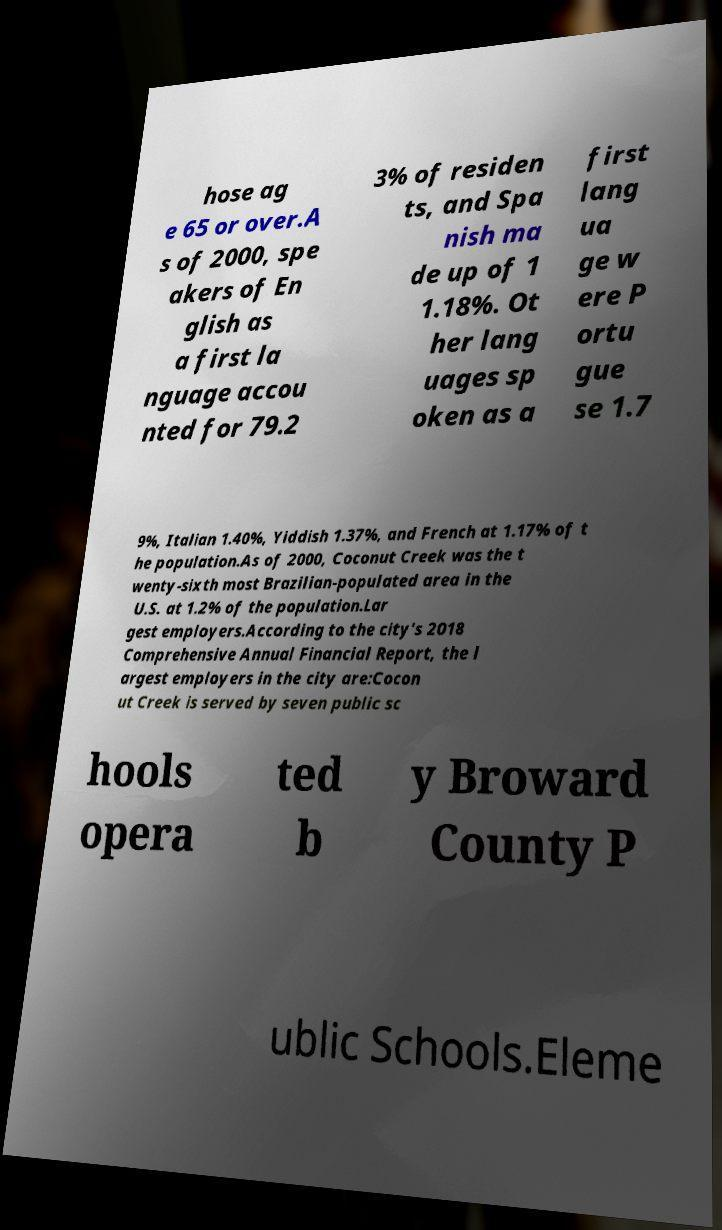I need the written content from this picture converted into text. Can you do that? hose ag e 65 or over.A s of 2000, spe akers of En glish as a first la nguage accou nted for 79.2 3% of residen ts, and Spa nish ma de up of 1 1.18%. Ot her lang uages sp oken as a first lang ua ge w ere P ortu gue se 1.7 9%, Italian 1.40%, Yiddish 1.37%, and French at 1.17% of t he population.As of 2000, Coconut Creek was the t wenty-sixth most Brazilian-populated area in the U.S. at 1.2% of the population.Lar gest employers.According to the city's 2018 Comprehensive Annual Financial Report, the l argest employers in the city are:Cocon ut Creek is served by seven public sc hools opera ted b y Broward County P ublic Schools.Eleme 